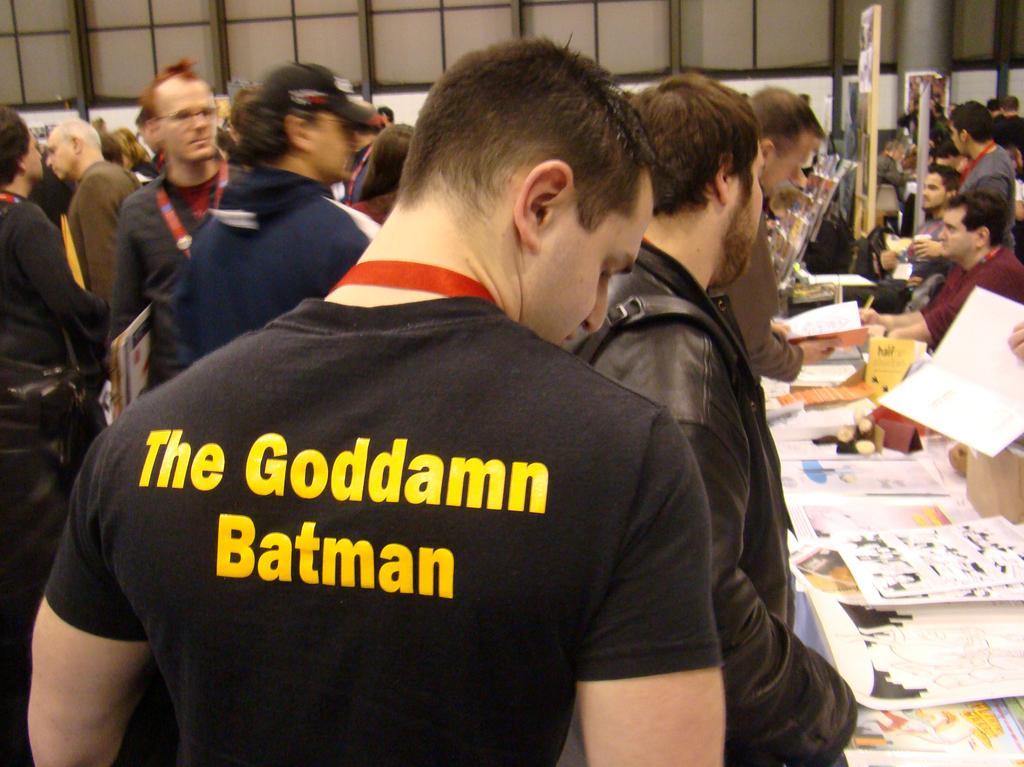How many people are in the image? There is a group of people in the image, but the exact number is not specified. What are the people in the image doing? Some people are standing, while others are sitting. What can be seen on the surface in front of the people? There are papers visible in the image. What is visible in the background of the image? There is a wall in the background of the image. What verse is being recited by the people in the image? There is no indication in the image that the people are reciting a verse, so it cannot be determined from the picture. 